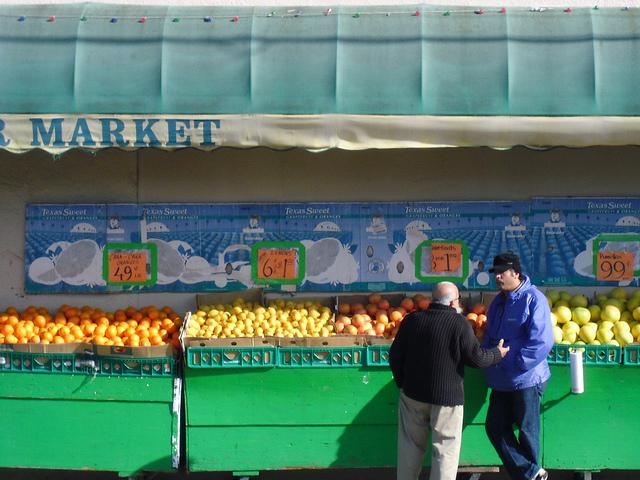What does the word on the awning say?
Concise answer only. Market. What are the two people on the right doing?
Keep it brief. Talking. Are the fruits fresh?
Answer briefly. Yes. 